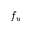<formula> <loc_0><loc_0><loc_500><loc_500>f _ { w }</formula> 